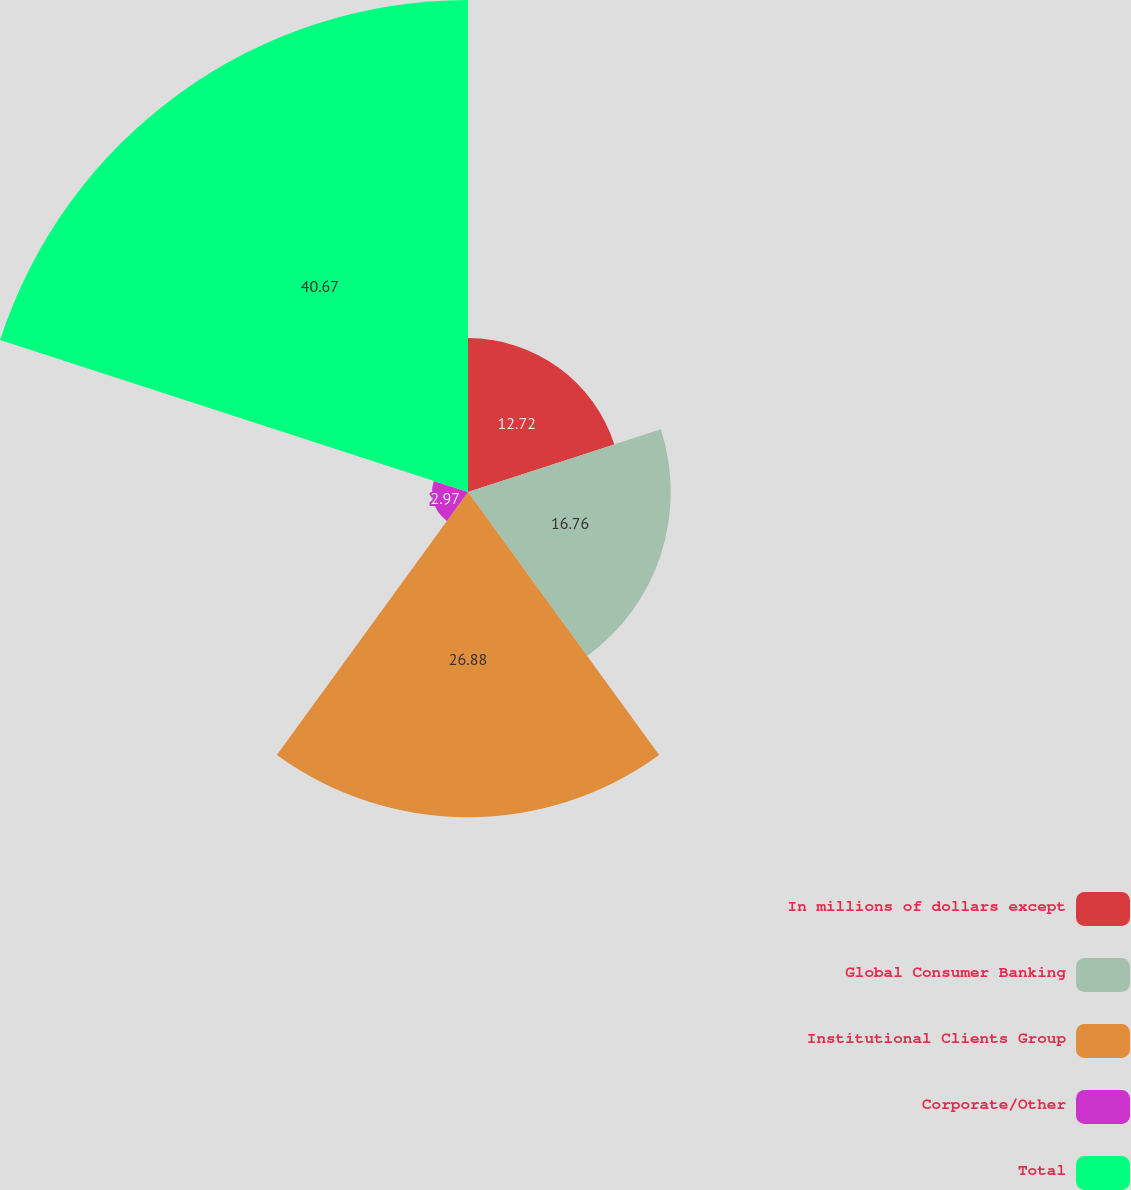<chart> <loc_0><loc_0><loc_500><loc_500><pie_chart><fcel>In millions of dollars except<fcel>Global Consumer Banking<fcel>Institutional Clients Group<fcel>Corporate/Other<fcel>Total<nl><fcel>12.72%<fcel>16.76%<fcel>26.88%<fcel>2.97%<fcel>40.67%<nl></chart> 